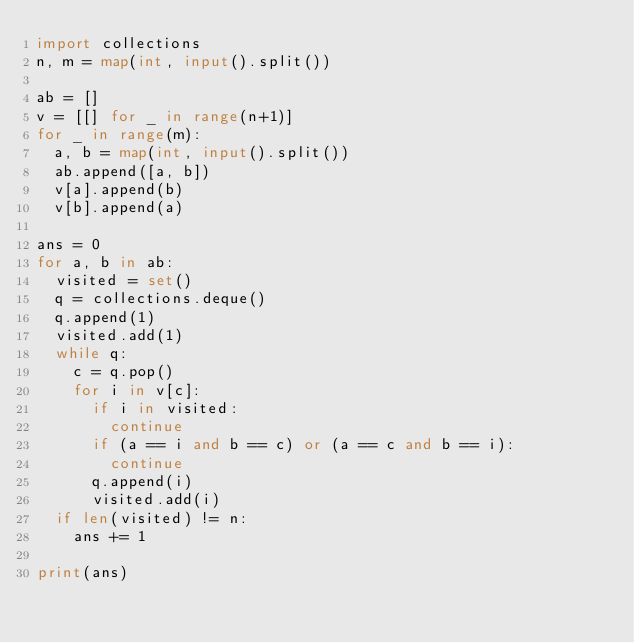<code> <loc_0><loc_0><loc_500><loc_500><_Python_>import collections
n, m = map(int, input().split())

ab = []
v = [[] for _ in range(n+1)]
for _ in range(m):
  a, b = map(int, input().split())
  ab.append([a, b])
  v[a].append(b)
  v[b].append(a)

ans = 0
for a, b in ab:
  visited = set()
  q = collections.deque()
  q.append(1)
  visited.add(1)
  while q:
    c = q.pop()
    for i in v[c]:
      if i in visited:
        continue
      if (a == i and b == c) or (a == c and b == i):
        continue
      q.append(i)
      visited.add(i)
  if len(visited) != n:
    ans += 1
    
print(ans)</code> 